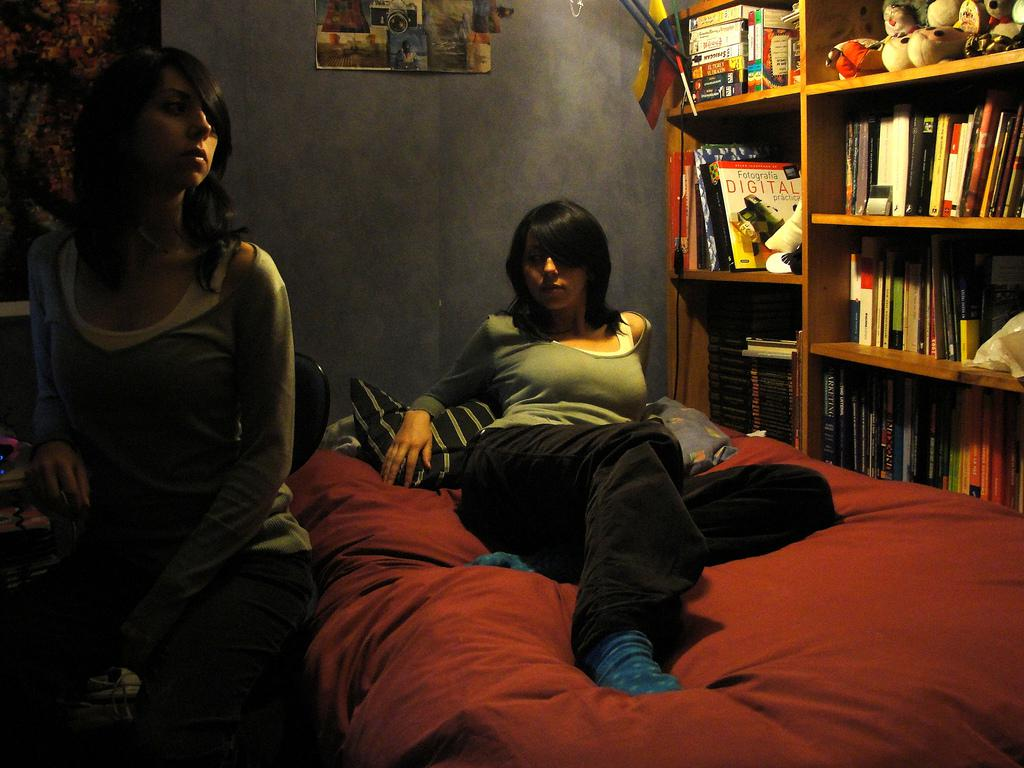Question: when was this picture taken?
Choices:
A. At night.
B. The day after the wedding.
C. In the morning.
D. It was taken yesterday.
Answer with the letter. Answer: A Question: how are the women dressed?
Choices:
A. Long-sleeved shirt and pants.
B. In their swim suits.
C. They are dressed in wedding gowns.
D. In long formal dresses.
Answer with the letter. Answer: A Question: what is the color of the women's shirt?
Choices:
A. Purple.
B. Blue.
C. Grey.
D. Pink.
Answer with the letter. Answer: C Question: what is the color of the blanket on the bed?
Choices:
A. Blue.
B. Grey.
C. White.
D. Red.
Answer with the letter. Answer: D Question: what is the color of the socks of the woman on the bed?
Choices:
A. Red.
B. Pink.
C. Yellow.
D. Blue.
Answer with the letter. Answer: D Question: what color of socks is the woman in bed wearing?
Choices:
A. Her socks are white.
B. Her socks are colored blue.
C. Black ones.
D. Blue ones.
Answer with the letter. Answer: B Question: what are the women doing?
Choices:
A. Playing cards.
B. Shopping.
C. Relaxing in a room.
D. Dancing.
Answer with the letter. Answer: C Question: what appear on the bookshelf?
Choices:
A. Books.
B. Stuffed animals.
C. Figurines.
D. DVDs.
Answer with the letter. Answer: B Question: what are the girls wearing?
Choices:
A. Matching tops.
B. Jeans.
C. Boots.
D. Matching bracelets.
Answer with the letter. Answer: A Question: who is laying on the striped pillow?
Choices:
A. My mom.
B. The mailman.
C. My pet dog.
D. One girl is laying on the pillow.
Answer with the letter. Answer: D Question: what is hanging on the wall?
Choices:
A. The keys.
B. Shoes.
C. A coat.
D. Pictures are hanging on the wall.
Answer with the letter. Answer: D Question: who is wearing the blue socks?
Choices:
A. The boy playing soccer.
B. The father of the boy.
C. The lady gardener.
D. The girl laying in the bed is wearing blue socks.
Answer with the letter. Answer: D Question: what is in the bookshelf?
Choices:
A. A candle.
B. Some pens.
C. Many books are placed in the bookshelf.
D. Picture frames.
Answer with the letter. Answer: C Question: what color is the wall behind the women?
Choices:
A. Dark gray.
B. Blue.
C. Pink.
D. Yellow.
Answer with the letter. Answer: A Question: where is the bookshelf?
Choices:
A. In the library.
B. Behind the door.
C. Next to the bed.
D. On the wall.
Answer with the letter. Answer: C Question: what is girl on the bed wearing?
Choices:
A. Yoga pants.
B. A hoodie.
C. Light top and dark pants.
D. Pajamas.
Answer with the letter. Answer: C Question: what kind of scene is it?
Choices:
A. A happy scene.
B. A scenic one.
C. A indoor scene.
D. A calm scene.
Answer with the letter. Answer: C Question: where is a girl looking at?
Choices:
A. To her right.
B. To her left.
C. Above her head.
D. Below her seat.
Answer with the letter. Answer: B Question: who is sitting down?
Choices:
A. The black cat.
B. The old man on the right.
C. The woman on the left.
D. The kid wearing the baseball cap.
Answer with the letter. Answer: C Question: where was this picture taken?
Choices:
A. In a bedroom.
B. In a museum.
C. In my friend's house.
D. In Niagara falls.
Answer with the letter. Answer: A 